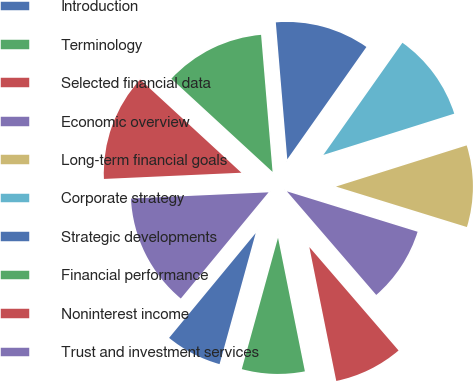<chart> <loc_0><loc_0><loc_500><loc_500><pie_chart><fcel>Introduction<fcel>Terminology<fcel>Selected financial data<fcel>Economic overview<fcel>Long-term financial goals<fcel>Corporate strategy<fcel>Strategic developments<fcel>Financial performance<fcel>Noninterest income<fcel>Trust and investment services<nl><fcel>6.71%<fcel>7.44%<fcel>8.17%<fcel>8.9%<fcel>9.63%<fcel>10.37%<fcel>11.1%<fcel>11.83%<fcel>12.56%<fcel>13.29%<nl></chart> 